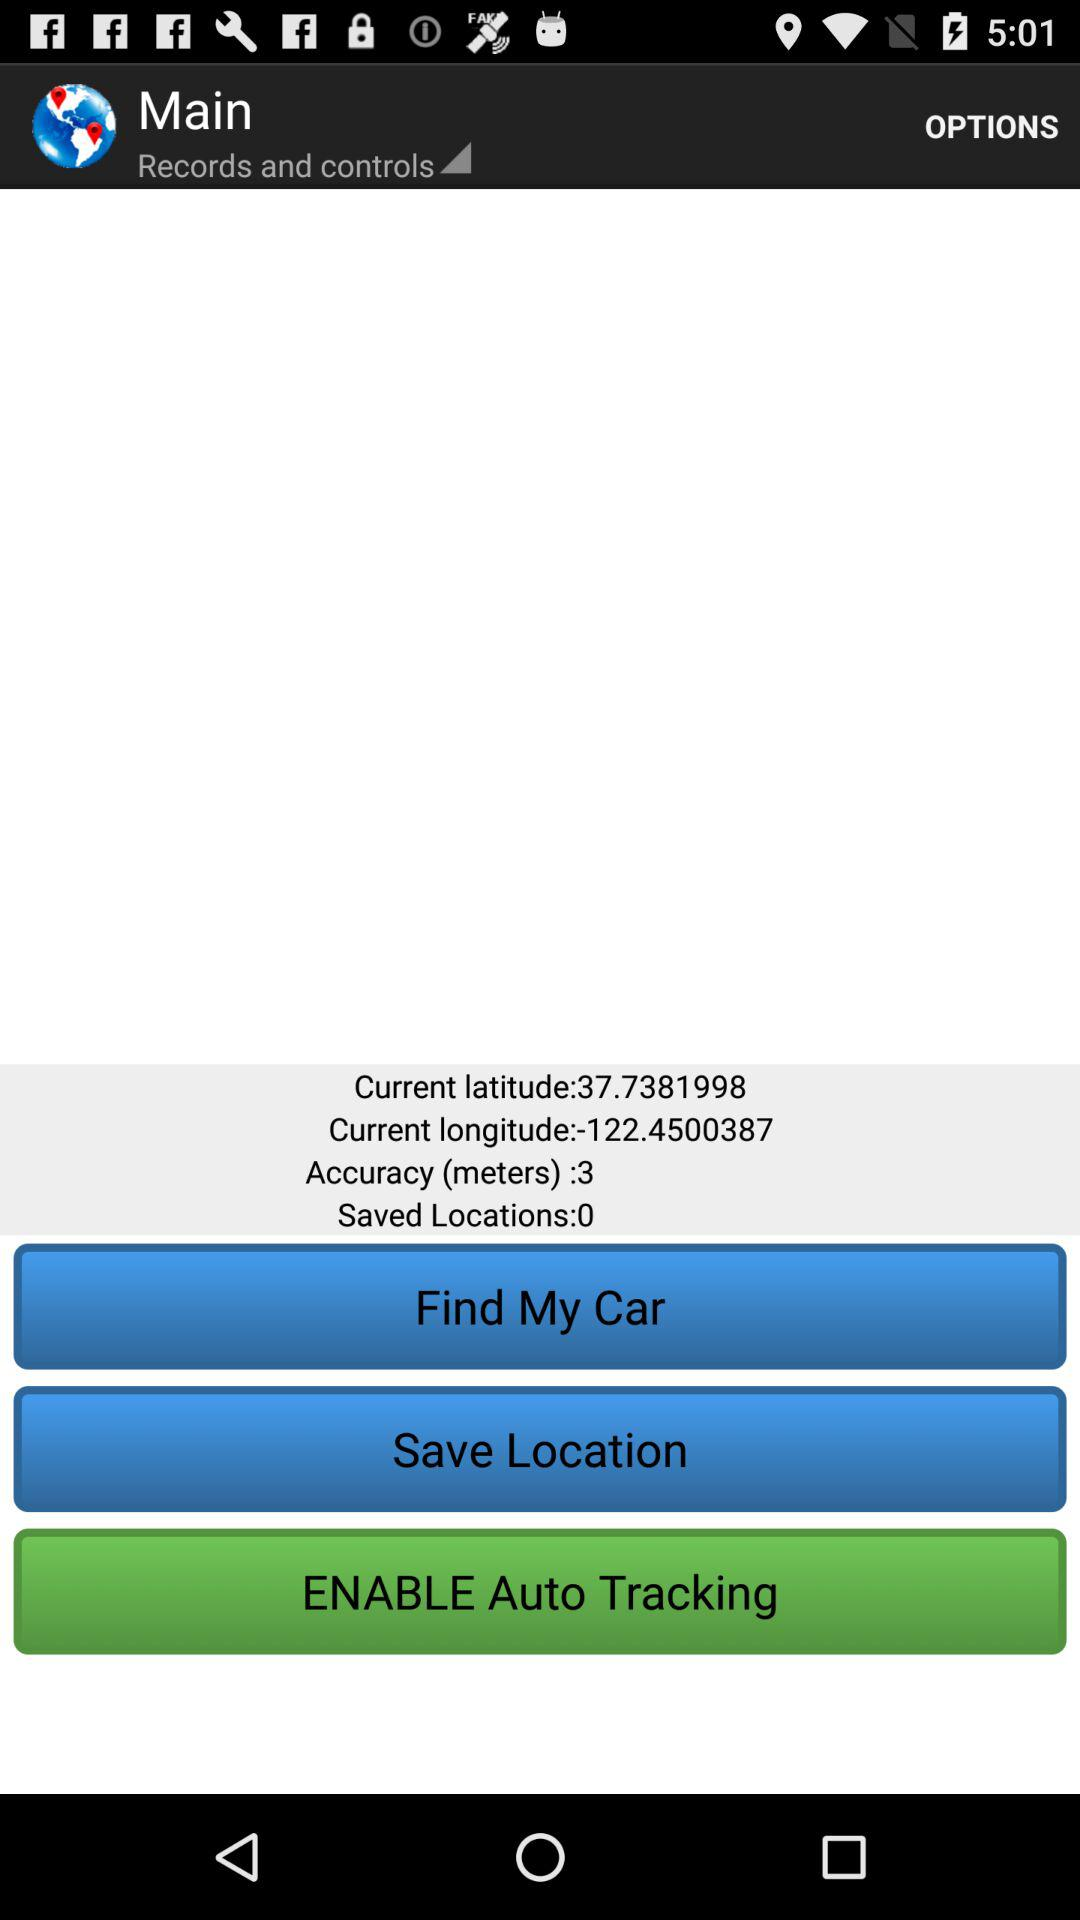How many saved locations are there?
Answer the question using a single word or phrase. 0 